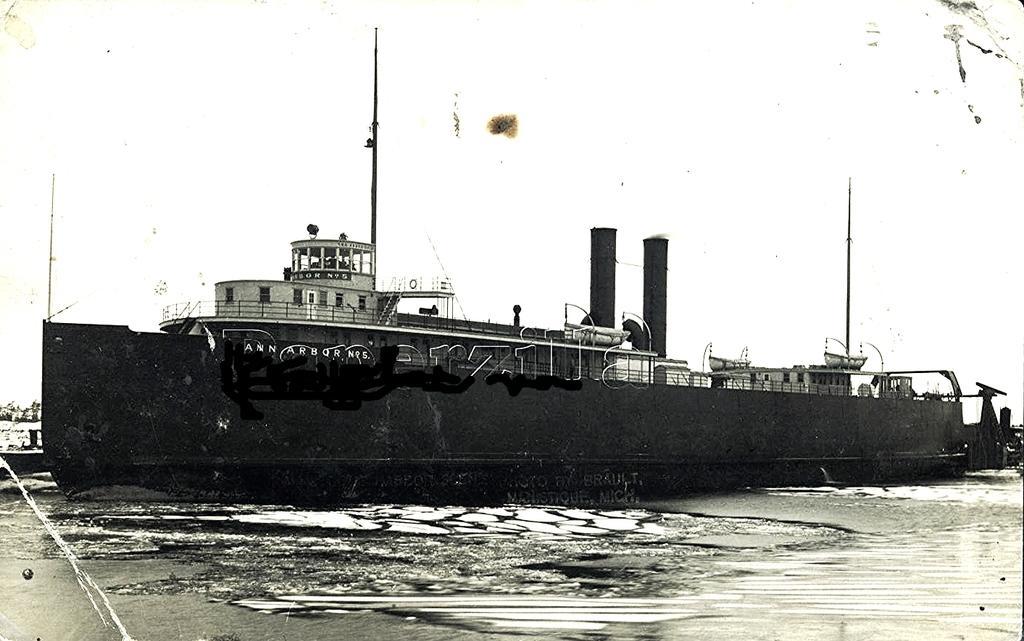Describe this image in one or two sentences. In this image in the middle there is a ship and at the bottom there is a water and background is the sky. 